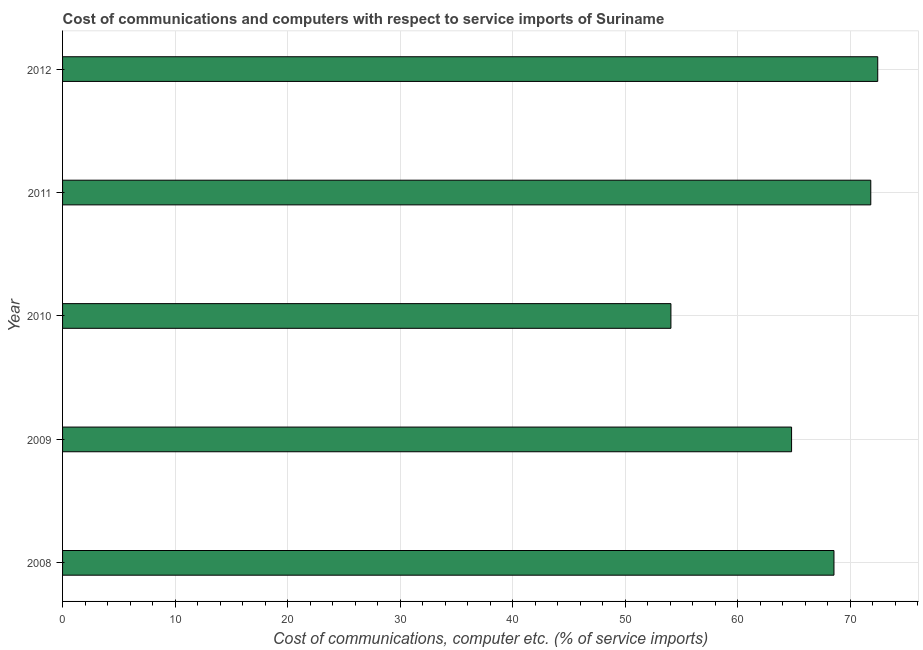Does the graph contain grids?
Ensure brevity in your answer.  Yes. What is the title of the graph?
Keep it short and to the point. Cost of communications and computers with respect to service imports of Suriname. What is the label or title of the X-axis?
Provide a succinct answer. Cost of communications, computer etc. (% of service imports). What is the cost of communications and computer in 2010?
Offer a very short reply. 54.05. Across all years, what is the maximum cost of communications and computer?
Make the answer very short. 72.43. Across all years, what is the minimum cost of communications and computer?
Offer a very short reply. 54.05. In which year was the cost of communications and computer maximum?
Make the answer very short. 2012. In which year was the cost of communications and computer minimum?
Your answer should be compact. 2010. What is the sum of the cost of communications and computer?
Give a very brief answer. 331.61. What is the difference between the cost of communications and computer in 2011 and 2012?
Your answer should be compact. -0.62. What is the average cost of communications and computer per year?
Provide a succinct answer. 66.32. What is the median cost of communications and computer?
Your response must be concise. 68.54. In how many years, is the cost of communications and computer greater than 62 %?
Provide a short and direct response. 4. What is the ratio of the cost of communications and computer in 2009 to that in 2012?
Offer a terse response. 0.89. What is the difference between the highest and the second highest cost of communications and computer?
Provide a short and direct response. 0.62. Is the sum of the cost of communications and computer in 2008 and 2009 greater than the maximum cost of communications and computer across all years?
Your answer should be very brief. Yes. What is the difference between the highest and the lowest cost of communications and computer?
Keep it short and to the point. 18.38. Are all the bars in the graph horizontal?
Keep it short and to the point. Yes. How many years are there in the graph?
Make the answer very short. 5. What is the Cost of communications, computer etc. (% of service imports) in 2008?
Make the answer very short. 68.54. What is the Cost of communications, computer etc. (% of service imports) in 2009?
Keep it short and to the point. 64.77. What is the Cost of communications, computer etc. (% of service imports) in 2010?
Make the answer very short. 54.05. What is the Cost of communications, computer etc. (% of service imports) in 2011?
Provide a succinct answer. 71.81. What is the Cost of communications, computer etc. (% of service imports) of 2012?
Keep it short and to the point. 72.43. What is the difference between the Cost of communications, computer etc. (% of service imports) in 2008 and 2009?
Provide a short and direct response. 3.77. What is the difference between the Cost of communications, computer etc. (% of service imports) in 2008 and 2010?
Give a very brief answer. 14.49. What is the difference between the Cost of communications, computer etc. (% of service imports) in 2008 and 2011?
Your response must be concise. -3.27. What is the difference between the Cost of communications, computer etc. (% of service imports) in 2008 and 2012?
Your response must be concise. -3.89. What is the difference between the Cost of communications, computer etc. (% of service imports) in 2009 and 2010?
Provide a succinct answer. 10.72. What is the difference between the Cost of communications, computer etc. (% of service imports) in 2009 and 2011?
Offer a terse response. -7.04. What is the difference between the Cost of communications, computer etc. (% of service imports) in 2009 and 2012?
Your response must be concise. -7.66. What is the difference between the Cost of communications, computer etc. (% of service imports) in 2010 and 2011?
Your answer should be compact. -17.76. What is the difference between the Cost of communications, computer etc. (% of service imports) in 2010 and 2012?
Provide a succinct answer. -18.38. What is the difference between the Cost of communications, computer etc. (% of service imports) in 2011 and 2012?
Offer a very short reply. -0.62. What is the ratio of the Cost of communications, computer etc. (% of service imports) in 2008 to that in 2009?
Make the answer very short. 1.06. What is the ratio of the Cost of communications, computer etc. (% of service imports) in 2008 to that in 2010?
Provide a succinct answer. 1.27. What is the ratio of the Cost of communications, computer etc. (% of service imports) in 2008 to that in 2011?
Offer a very short reply. 0.95. What is the ratio of the Cost of communications, computer etc. (% of service imports) in 2008 to that in 2012?
Make the answer very short. 0.95. What is the ratio of the Cost of communications, computer etc. (% of service imports) in 2009 to that in 2010?
Offer a very short reply. 1.2. What is the ratio of the Cost of communications, computer etc. (% of service imports) in 2009 to that in 2011?
Make the answer very short. 0.9. What is the ratio of the Cost of communications, computer etc. (% of service imports) in 2009 to that in 2012?
Your answer should be compact. 0.89. What is the ratio of the Cost of communications, computer etc. (% of service imports) in 2010 to that in 2011?
Provide a short and direct response. 0.75. What is the ratio of the Cost of communications, computer etc. (% of service imports) in 2010 to that in 2012?
Your answer should be compact. 0.75. 